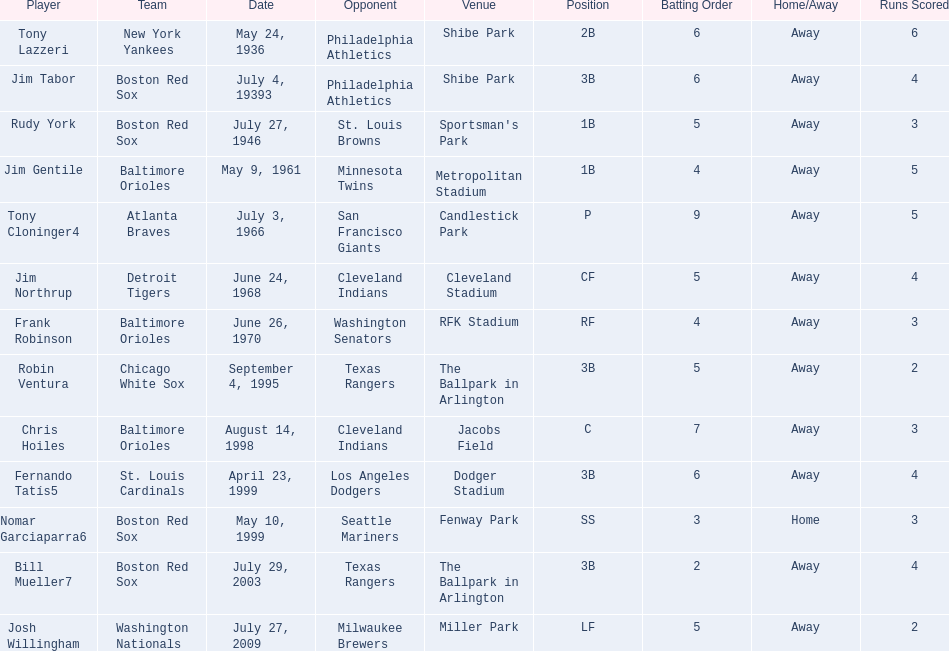Which teams played between the years 1960 and 1970? Baltimore Orioles, Atlanta Braves, Detroit Tigers, Baltimore Orioles. Of these teams that played, which ones played against the cleveland indians? Detroit Tigers. On what day did these two teams play? June 24, 1968. 